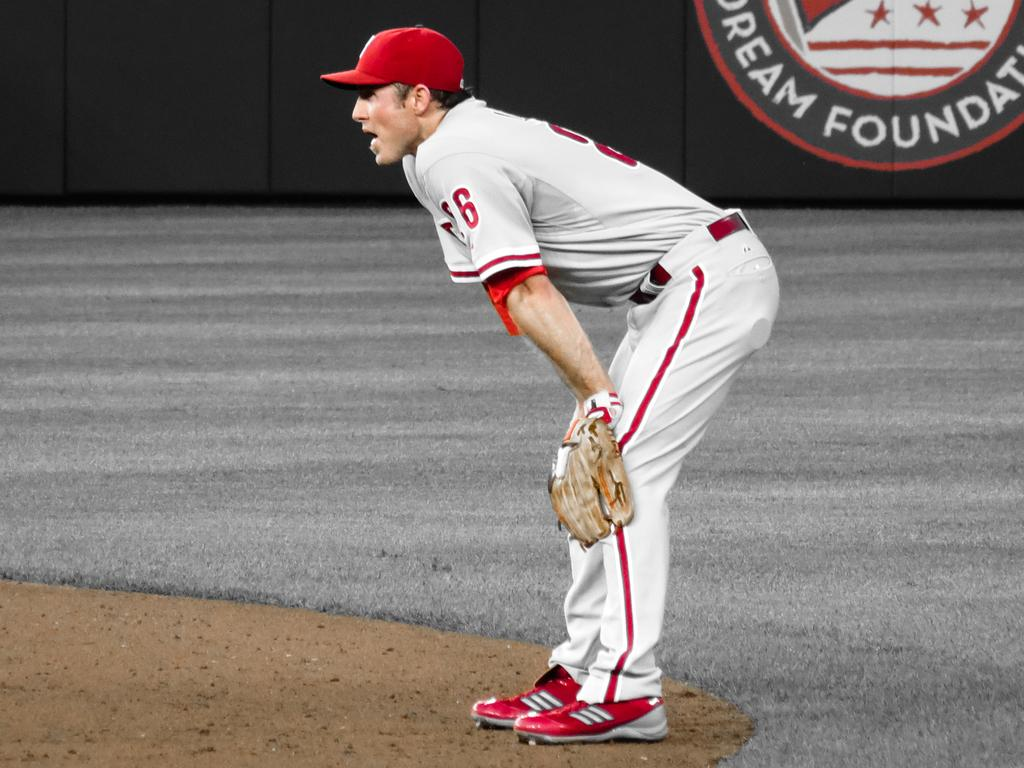<image>
Write a terse but informative summary of the picture. a baseball player in front of a banner that says 'dream foundation' on it 